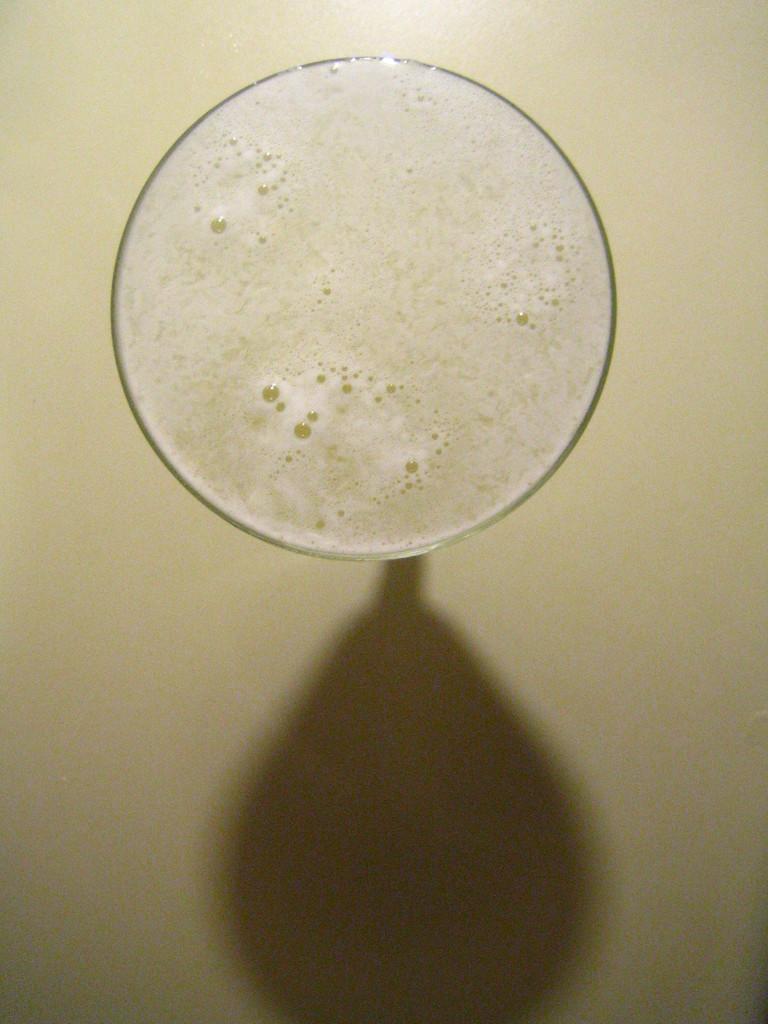Can you describe this image briefly? In this picture there is a drink in the glass. At the bottom there is a shadow of the glass on the floor. 